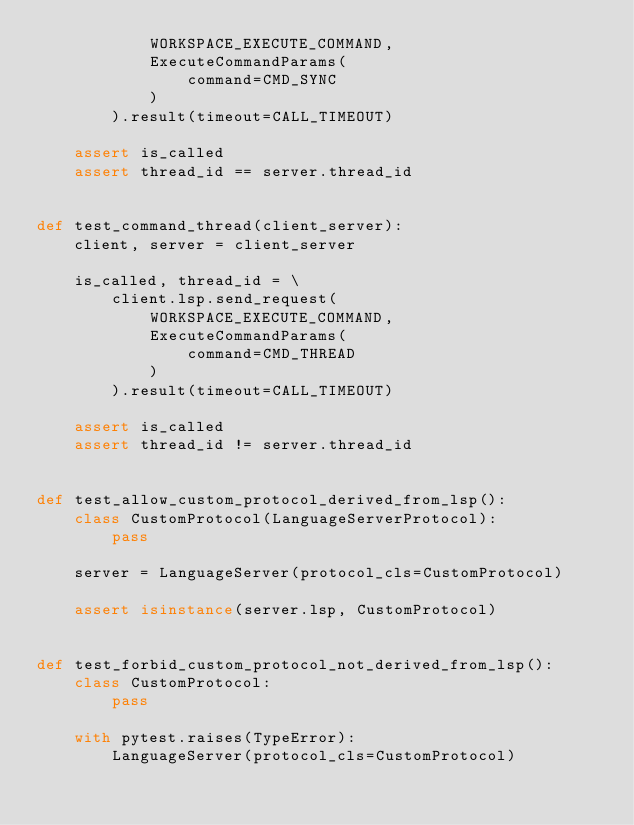<code> <loc_0><loc_0><loc_500><loc_500><_Python_>            WORKSPACE_EXECUTE_COMMAND,
            ExecuteCommandParams(
                command=CMD_SYNC
            )
        ).result(timeout=CALL_TIMEOUT)

    assert is_called
    assert thread_id == server.thread_id


def test_command_thread(client_server):
    client, server = client_server

    is_called, thread_id = \
        client.lsp.send_request(
            WORKSPACE_EXECUTE_COMMAND,
            ExecuteCommandParams(
                command=CMD_THREAD
            )
        ).result(timeout=CALL_TIMEOUT)

    assert is_called
    assert thread_id != server.thread_id


def test_allow_custom_protocol_derived_from_lsp():
    class CustomProtocol(LanguageServerProtocol):
        pass

    server = LanguageServer(protocol_cls=CustomProtocol)

    assert isinstance(server.lsp, CustomProtocol)


def test_forbid_custom_protocol_not_derived_from_lsp():
    class CustomProtocol:
        pass

    with pytest.raises(TypeError):
        LanguageServer(protocol_cls=CustomProtocol)
</code> 